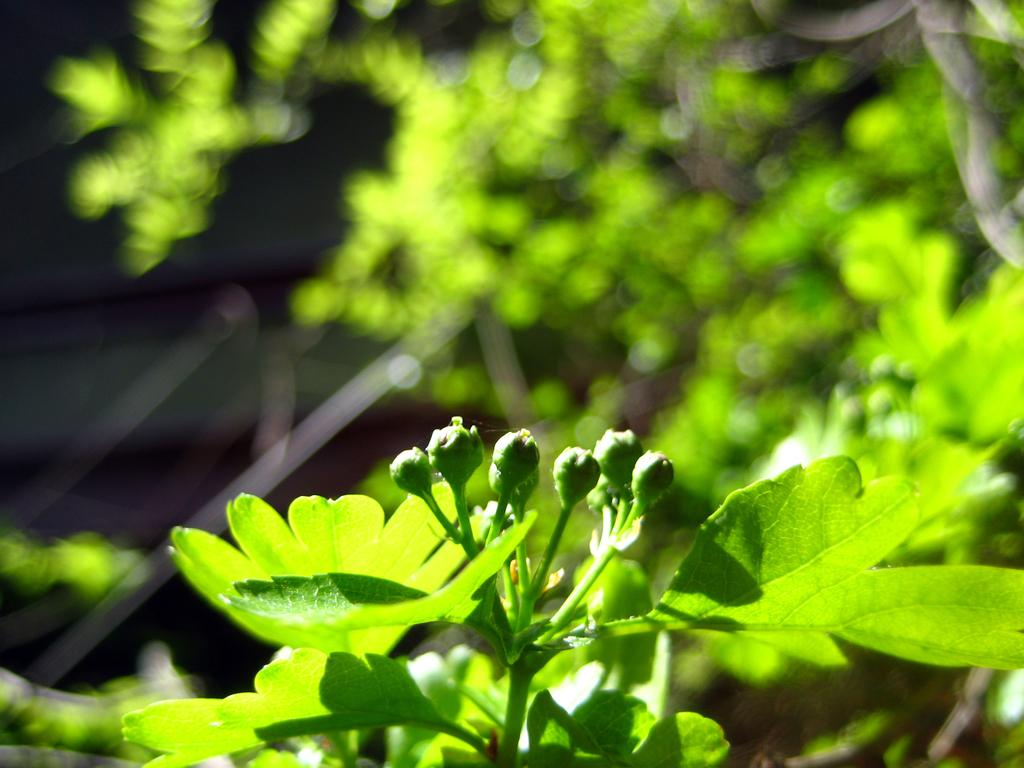What type of plant is present in the image? There are flowers on a plant in the image. What other natural elements can be seen in the image? There are trees visible in the image. How are the trees depicted in the image? The trees are in a blurry manner in the image. What type of chair is visible in the image? There is no chair present in the image. What error can be seen in the image? There is no error present in the image; it is a clear depiction of flowers on a plant and trees in the background. 